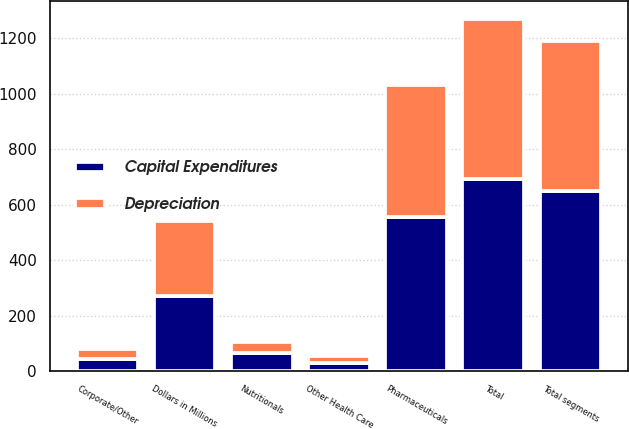<chart> <loc_0><loc_0><loc_500><loc_500><stacked_bar_chart><ecel><fcel>Dollars in Millions<fcel>Pharmaceuticals<fcel>Nutritionals<fcel>Other Health Care<fcel>Total segments<fcel>Corporate/Other<fcel>Total<nl><fcel>Capital Expenditures<fcel>271<fcel>554<fcel>65<fcel>30<fcel>649<fcel>44<fcel>693<nl><fcel>Depreciation<fcel>271<fcel>477<fcel>38<fcel>25<fcel>540<fcel>37<fcel>577<nl></chart> 